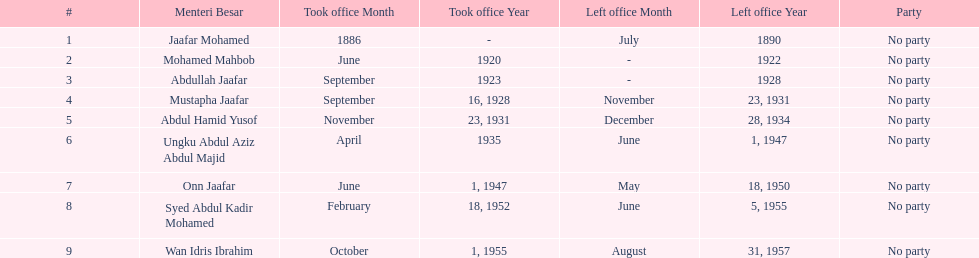How many years was jaafar mohamed in office? 4. 